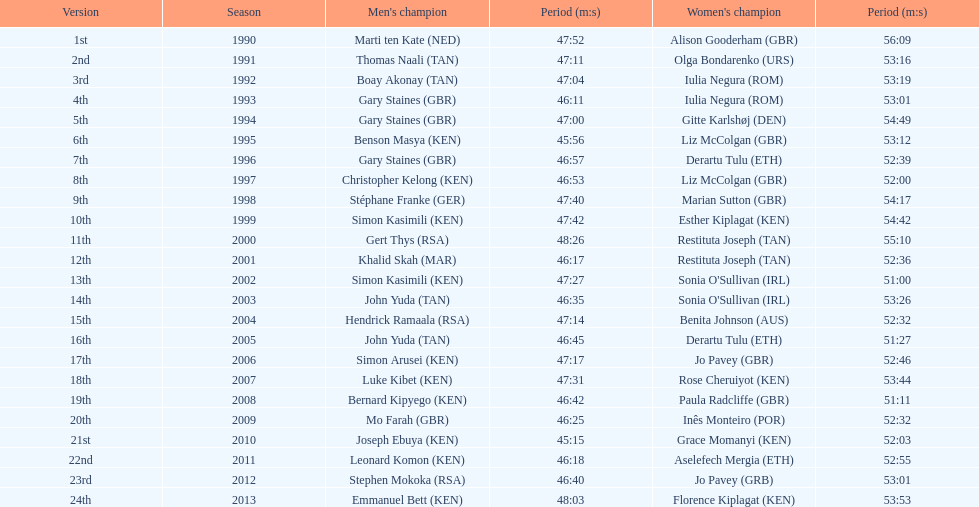Which runners are from kenya? (ken) Benson Masya (KEN), Christopher Kelong (KEN), Simon Kasimili (KEN), Simon Kasimili (KEN), Simon Arusei (KEN), Luke Kibet (KEN), Bernard Kipyego (KEN), Joseph Ebuya (KEN), Leonard Komon (KEN), Emmanuel Bett (KEN). Of these, which times are under 46 minutes? Benson Masya (KEN), Joseph Ebuya (KEN). Which of these runners had the faster time? Joseph Ebuya (KEN). 